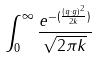<formula> <loc_0><loc_0><loc_500><loc_500>\int _ { 0 } ^ { \infty } \frac { e ^ { - ( \frac { ( q \cdot g ) ^ { 2 } } { 2 k } ) } } { \sqrt { 2 \pi k } }</formula> 